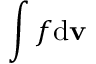<formula> <loc_0><loc_0><loc_500><loc_500>\int f d { \mathbf v }</formula> 